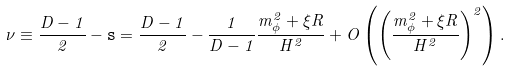<formula> <loc_0><loc_0><loc_500><loc_500>\nu \equiv \frac { D - 1 } { 2 } - { \tt s } = \frac { D - 1 } { 2 } - \frac { 1 } { D - 1 } \frac { m _ { \phi } ^ { 2 } + \xi R } { H ^ { 2 } } + O \left ( \left ( \frac { m _ { \phi } ^ { 2 } + \xi R } { H ^ { 2 } } \right ) ^ { 2 } \right ) .</formula> 